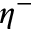<formula> <loc_0><loc_0><loc_500><loc_500>\eta ^ { - }</formula> 